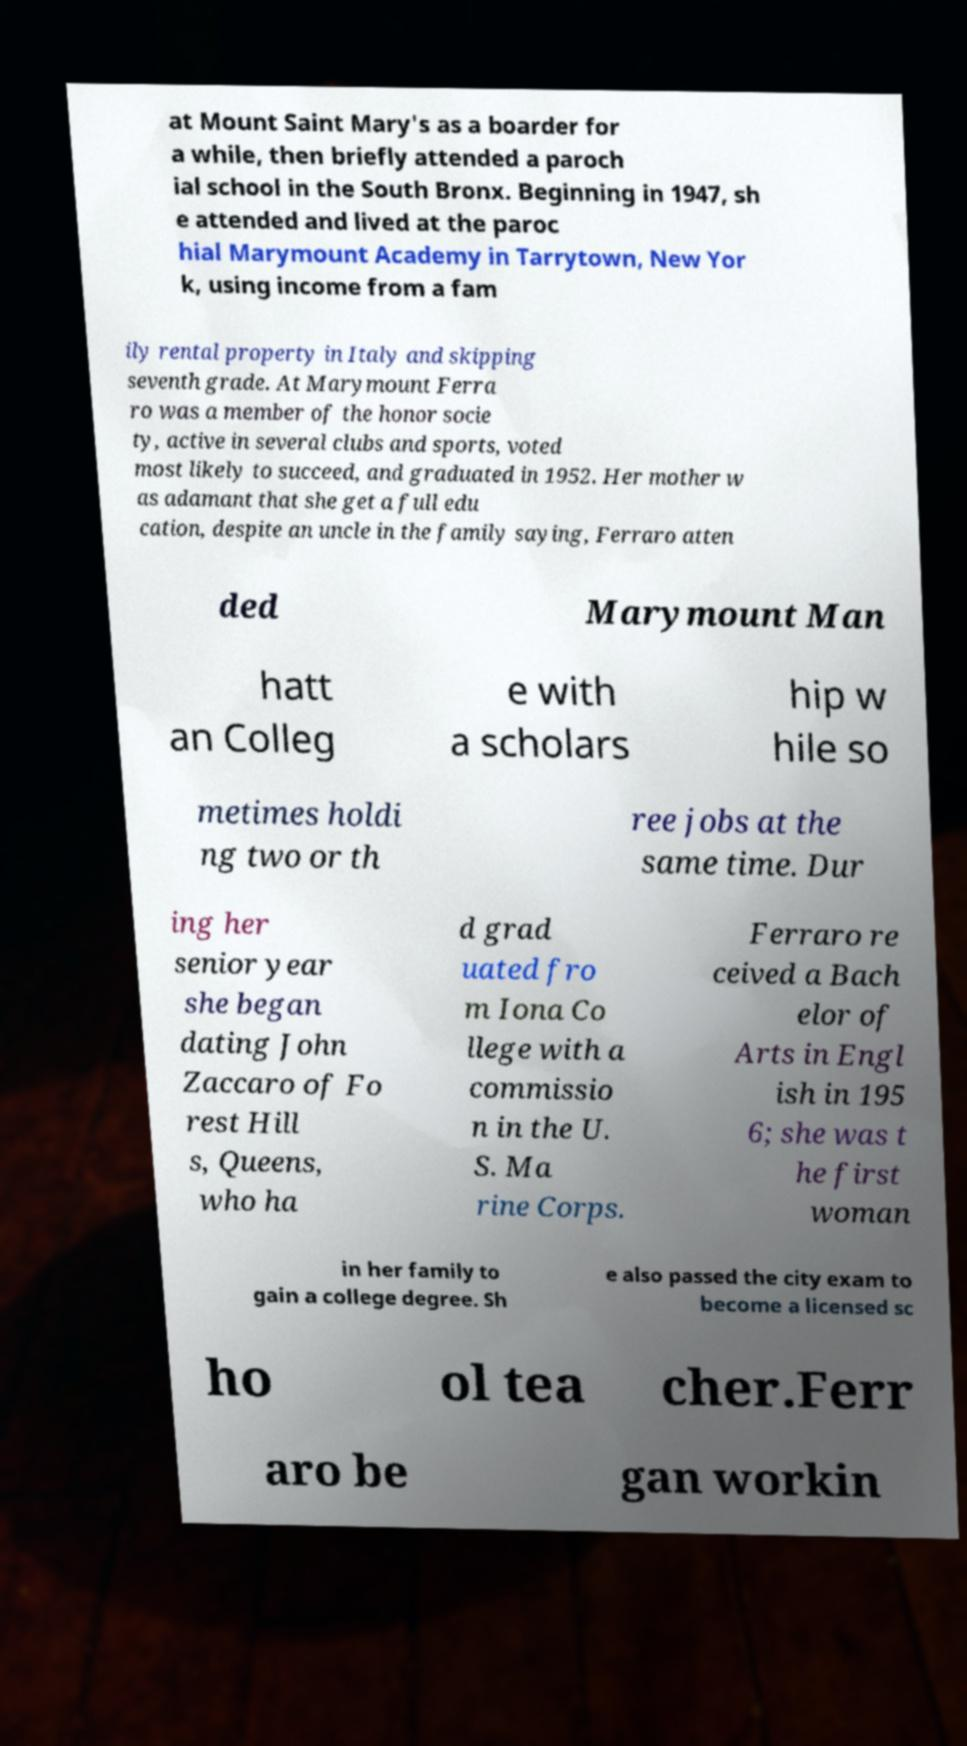Please identify and transcribe the text found in this image. at Mount Saint Mary's as a boarder for a while, then briefly attended a paroch ial school in the South Bronx. Beginning in 1947, sh e attended and lived at the paroc hial Marymount Academy in Tarrytown, New Yor k, using income from a fam ily rental property in Italy and skipping seventh grade. At Marymount Ferra ro was a member of the honor socie ty, active in several clubs and sports, voted most likely to succeed, and graduated in 1952. Her mother w as adamant that she get a full edu cation, despite an uncle in the family saying, Ferraro atten ded Marymount Man hatt an Colleg e with a scholars hip w hile so metimes holdi ng two or th ree jobs at the same time. Dur ing her senior year she began dating John Zaccaro of Fo rest Hill s, Queens, who ha d grad uated fro m Iona Co llege with a commissio n in the U. S. Ma rine Corps. Ferraro re ceived a Bach elor of Arts in Engl ish in 195 6; she was t he first woman in her family to gain a college degree. Sh e also passed the city exam to become a licensed sc ho ol tea cher.Ferr aro be gan workin 